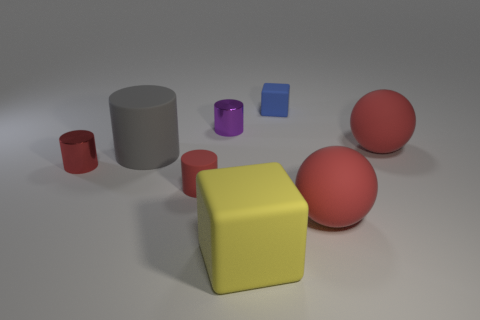There is a block in front of the purple object; is it the same size as the red thing that is in front of the small red rubber object?
Offer a very short reply. Yes. There is a red object that is both to the left of the large yellow object and behind the red matte cylinder; what shape is it?
Keep it short and to the point. Cylinder. Is there a big blue object that has the same material as the tiny blue thing?
Your response must be concise. No. What material is the other cylinder that is the same color as the tiny rubber cylinder?
Offer a very short reply. Metal. Is the material of the ball that is behind the red metal cylinder the same as the tiny cylinder that is behind the red shiny object?
Ensure brevity in your answer.  No. Are there more red cylinders than big purple matte spheres?
Give a very brief answer. Yes. There is a large matte ball that is in front of the small matte thing on the left side of the matte block that is behind the large yellow matte object; what is its color?
Provide a succinct answer. Red. Do the matte block behind the red metallic cylinder and the block that is on the left side of the blue cube have the same color?
Offer a terse response. No. How many tiny rubber things are to the right of the big rubber object that is left of the large yellow block?
Ensure brevity in your answer.  2. Is there a small cyan shiny cylinder?
Ensure brevity in your answer.  No. 